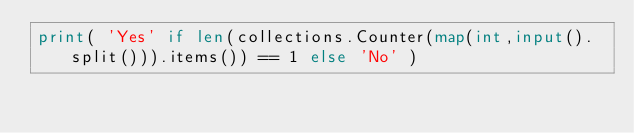Convert code to text. <code><loc_0><loc_0><loc_500><loc_500><_Python_>print( 'Yes' if len(collections.Counter(map(int,input().split())).items()) == 1 else 'No' )</code> 